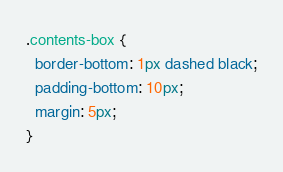<code> <loc_0><loc_0><loc_500><loc_500><_CSS_>.contents-box {
  border-bottom: 1px dashed black;
  padding-bottom: 10px;
  margin: 5px;
}
</code> 